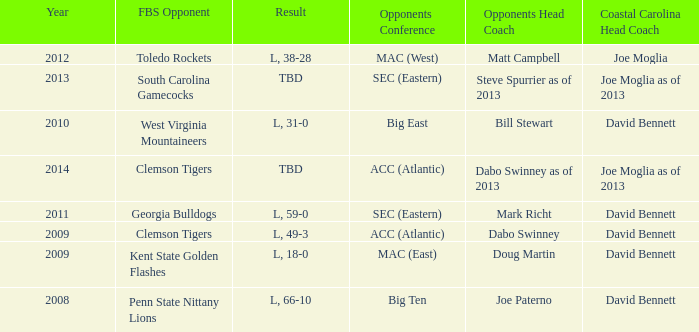Who was the coastal Carolina head coach in 2013? Joe Moglia as of 2013. Could you parse the entire table as a dict? {'header': ['Year', 'FBS Opponent', 'Result', 'Opponents Conference', 'Opponents Head Coach', 'Coastal Carolina Head Coach'], 'rows': [['2012', 'Toledo Rockets', 'L, 38-28', 'MAC (West)', 'Matt Campbell', 'Joe Moglia'], ['2013', 'South Carolina Gamecocks', 'TBD', 'SEC (Eastern)', 'Steve Spurrier as of 2013', 'Joe Moglia as of 2013'], ['2010', 'West Virginia Mountaineers', 'L, 31-0', 'Big East', 'Bill Stewart', 'David Bennett'], ['2014', 'Clemson Tigers', 'TBD', 'ACC (Atlantic)', 'Dabo Swinney as of 2013', 'Joe Moglia as of 2013'], ['2011', 'Georgia Bulldogs', 'L, 59-0', 'SEC (Eastern)', 'Mark Richt', 'David Bennett'], ['2009', 'Clemson Tigers', 'L, 49-3', 'ACC (Atlantic)', 'Dabo Swinney', 'David Bennett'], ['2009', 'Kent State Golden Flashes', 'L, 18-0', 'MAC (East)', 'Doug Martin', 'David Bennett'], ['2008', 'Penn State Nittany Lions', 'L, 66-10', 'Big Ten', 'Joe Paterno', 'David Bennett']]} 